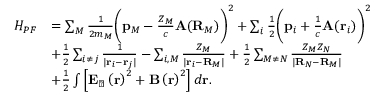<formula> <loc_0><loc_0><loc_500><loc_500>\begin{array} { r l } { H _ { P F } } & { = \sum _ { M } \frac { 1 } { 2 m _ { M } } \left ( p _ { M } - \frac { Z _ { M } } { c } A ( R _ { M } ) \right ) ^ { 2 } + \sum _ { i } \frac { 1 } { 2 } \left ( p _ { i } + \frac { 1 } { c } A ( r _ { i } ) \right ) ^ { 2 } } \\ & { + \frac { 1 } { 2 } \sum _ { i \neq j } \frac { 1 } { | r _ { i } - r _ { j } | } - \sum _ { i , M } \frac { Z _ { M } } { | r _ { i } - R _ { M } | } + \frac { 1 } { 2 } \sum _ { M \neq N } \frac { Z _ { M } Z _ { N } } { | R _ { N } - R _ { M } | } } \\ & { + \frac { 1 } { 2 } \int \left [ E _ { \perp } \left ( r \right ) ^ { 2 } + B \left ( r \right ) ^ { 2 } \right ] d r . } \end{array}</formula> 